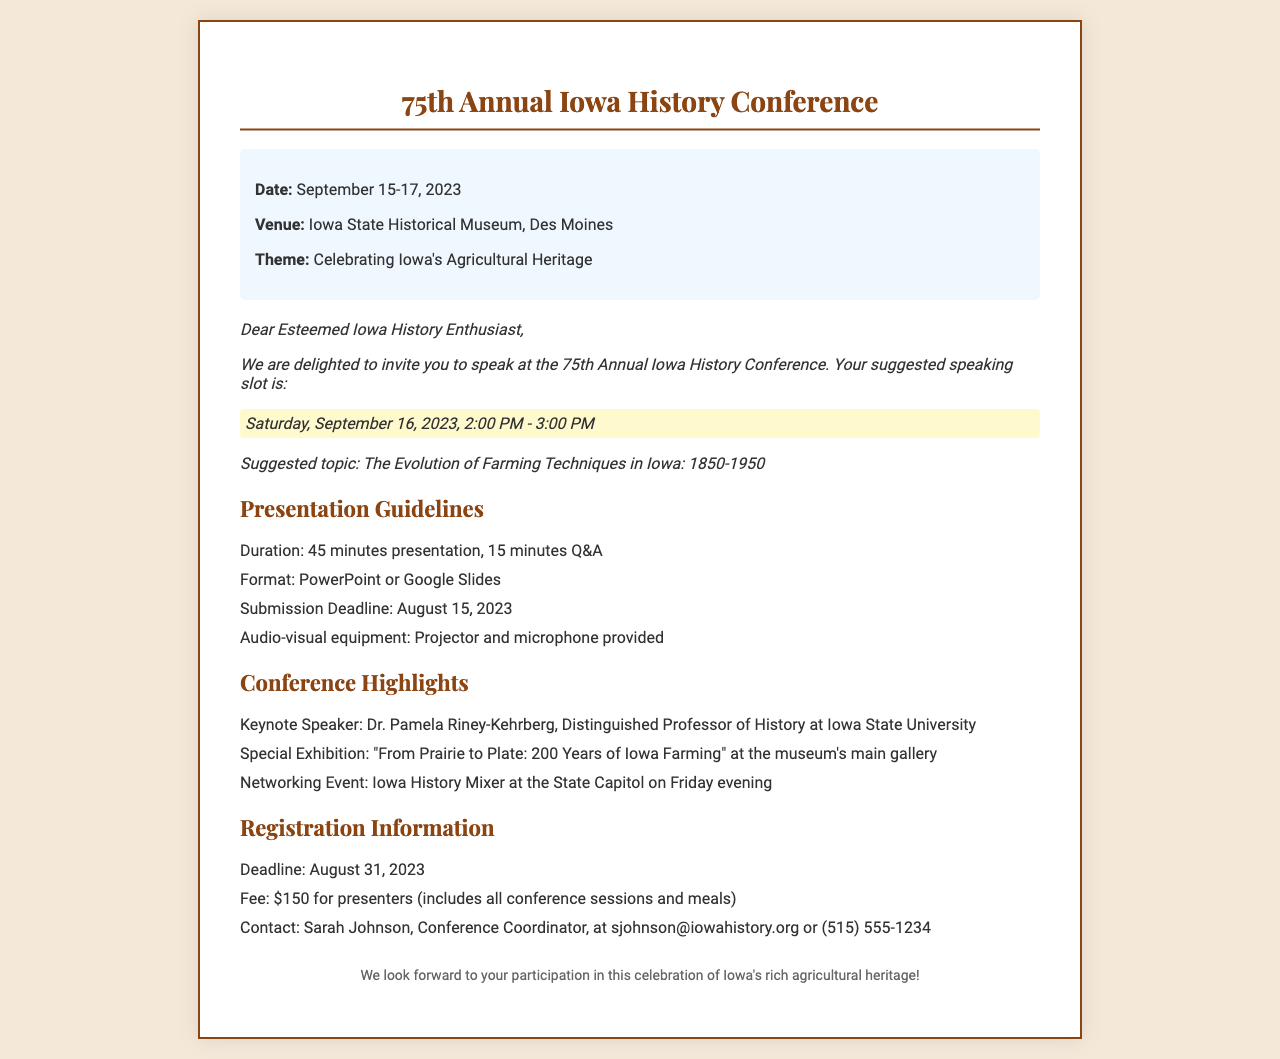What is the date of the conference? The date is provided in the document under event details.
Answer: September 15-17, 2023 Who is the keynote speaker? The document lists the keynote speaker in the conference highlights section.
Answer: Dr. Pamela Riney-Kehrberg What is the theme of the conference? The theme is highlighted in the event details section of the document.
Answer: Celebrating Iowa's Agricultural Heritage What is the suggested topic for the presentation? The suggested topic is mentioned in the invitation section.
Answer: The Evolution of Farming Techniques in Iowa: 1850-1950 When is the presentation submission deadline? The deadline for submission is stated in the presentation guidelines.
Answer: August 15, 2023 What is the registration deadline? The registration deadline can be found in the registration information section.
Answer: August 31, 2023 What is the fee for presenters? The fee information is included in the registration information.
Answer: $150 What is the duration of the presentation? This information can be found in the presentation guidelines section of the document.
Answer: 45 minutes presentation, 15 minutes Q&A Where is the conference venue? The venue is specified in the event details section of the document.
Answer: Iowa State Historical Museum, Des Moines 